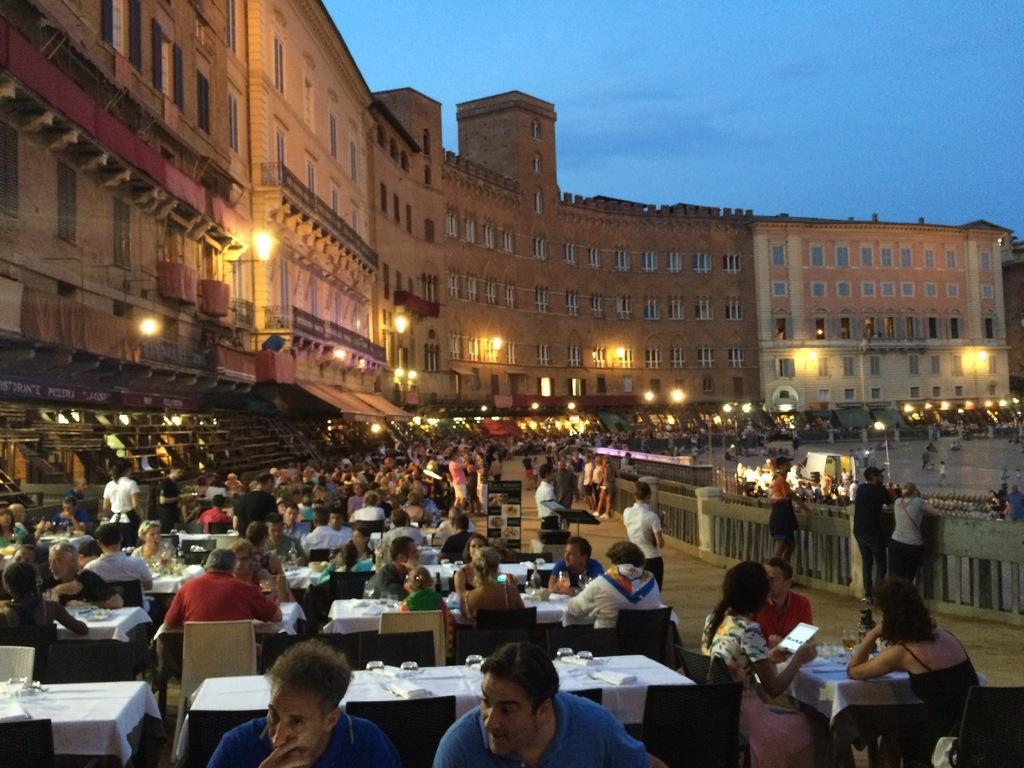Could you give a brief overview of what you see in this image? In this image there are few tables and chairs on the floor. Few persons are sitting on the chairs. Right side there is a fence. Few persons are standing near the fence. Background there are few buildings having few lights attached to the wall. Behind the fence there are few persons. Top of the image there is sky. 